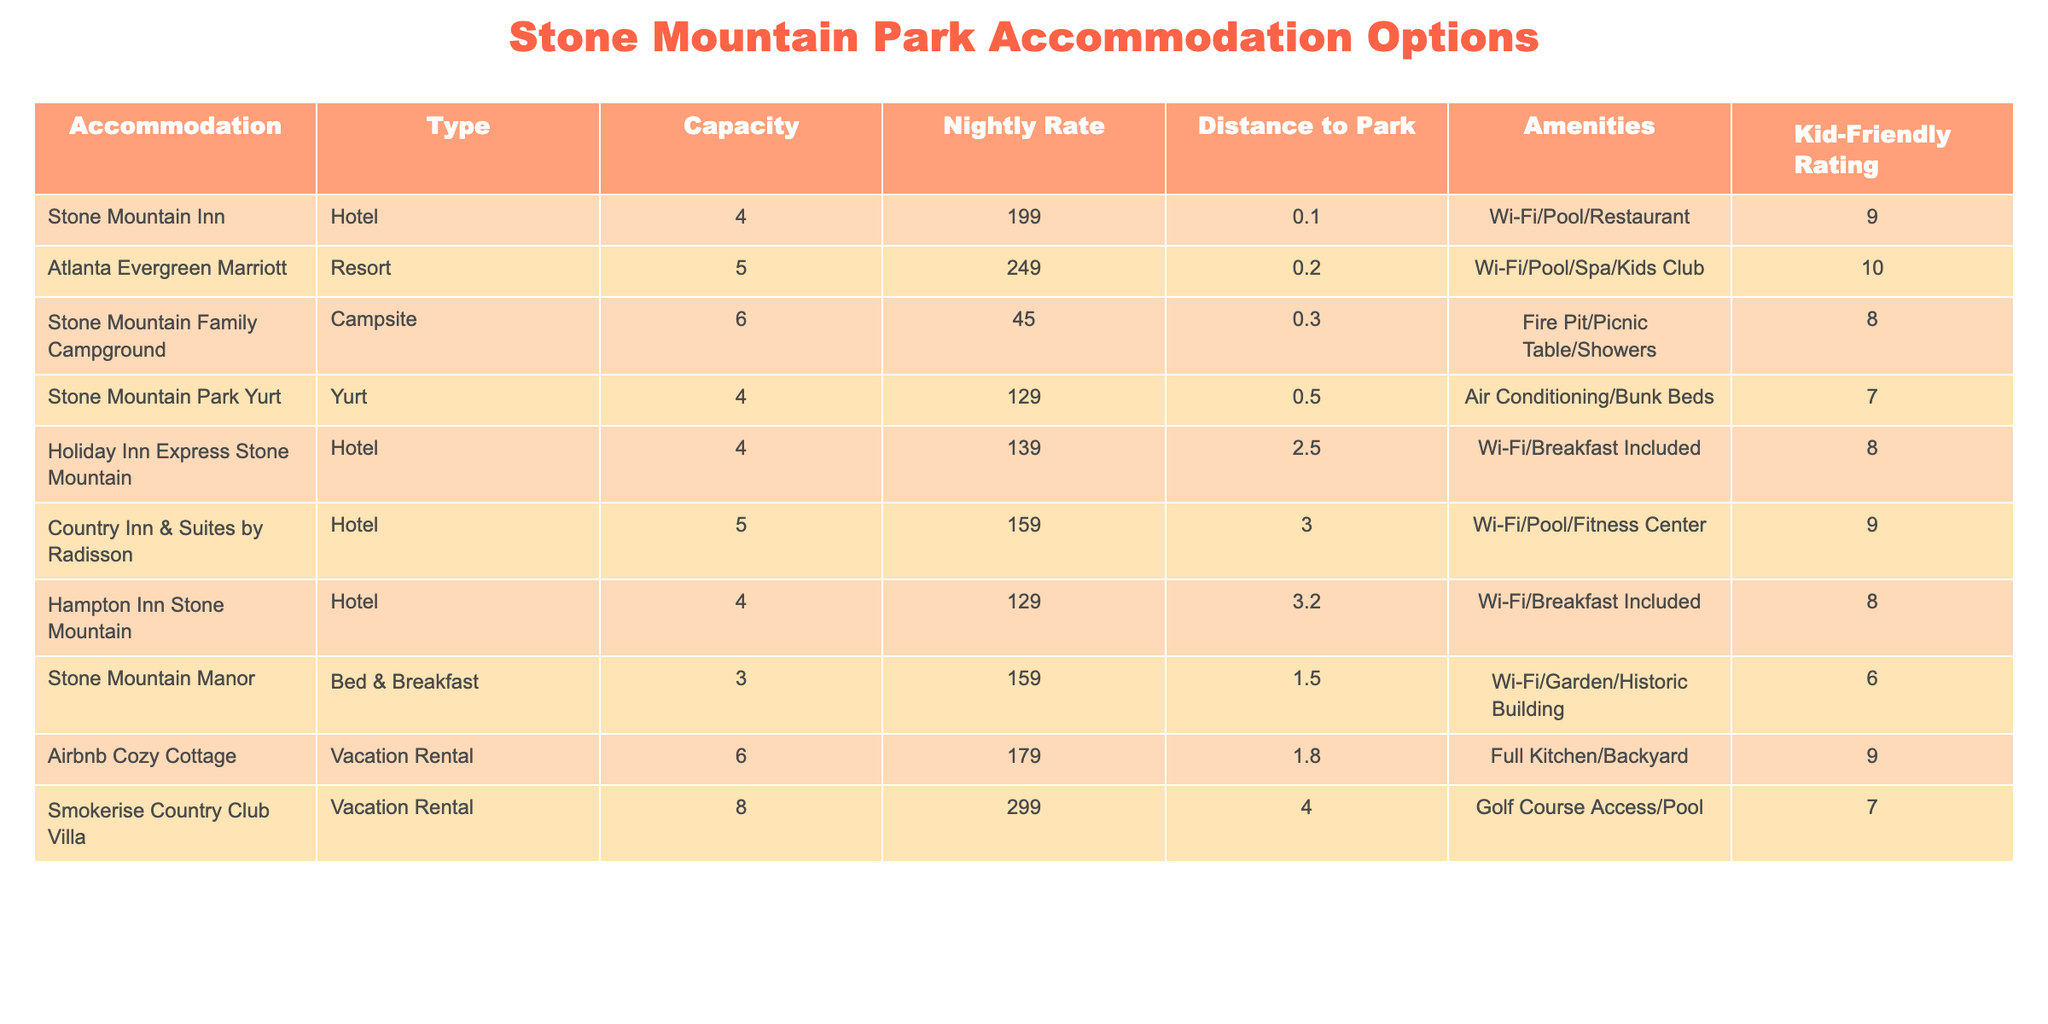What is the nightly rate of the Atlanta Evergreen Marriott? The table lists the nightly rate for the Atlanta Evergreen Marriott under the "Nightly Rate" column, which is 249.
Answer: 249 How many people can stay at the Stone Mountain Family Campground? The capacity for the Stone Mountain Family Campground is listed as 6 under the "Capacity" column.
Answer: 6 Is there a swimming pool available at the Stone Mountain Inn? The amenities listed for the Stone Mountain Inn include a swimming pool, meaning it does have this feature.
Answer: Yes Which accommodation has the highest kid-friendly rating? By comparing kid-friendly ratings across all accommodations, the Atlanta Evergreen Marriott has the highest rating of 10.
Answer: Atlanta Evergreen Marriott What is the average nightly rate of all accommodations listed? The sum of all nightly rates is (199 + 249 + 45 + 129 + 139 + 159 + 129 + 159 + 179 + 299) = 1,577. There are 10 accommodations, so the average is 1,577/10 = 157.7.
Answer: 157.7 How far is the Holiday Inn Express Stone Mountain from the park? The table shows that the distance to the park from the Holiday Inn Express Stone Mountain is 2.5.
Answer: 2.5 miles Which accommodation option is the closest to Stone Mountain Park? The Stone Mountain Inn is listed with a distance of 0.1, making it the closest option to the park.
Answer: Stone Mountain Inn What is the difference in nightly rate between the cheapest and the most expensive accommodation? The cheapest accommodation is the Stone Mountain Family Campground at 45, and the most expensive is the Smokerise Country Club Villa at 299. The difference is 299 - 45 = 254.
Answer: 254 Does the Airbnb Cozy Cottage have air conditioning? The table does not list air conditioning as an amenity for the Airbnb Cozy Cottage, so it can be concluded that this accommodation does not have air conditioning.
Answer: No Which accommodation type has the lowest kid-friendly rating and what is it? The Stone Mountain Manor has the lowest kid-friendly rating of 6, which can be found under the "Kid-Friendly Rating" column.
Answer: Bed & Breakfast, Rating 6 